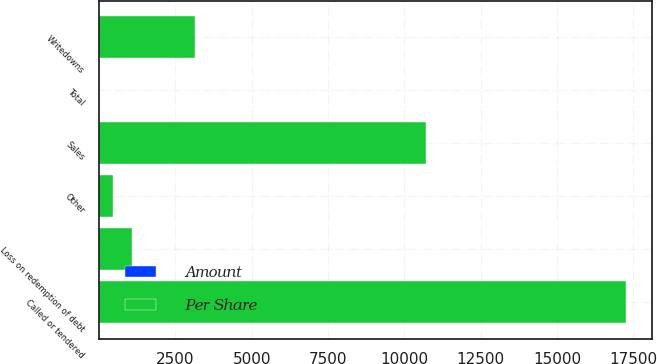<chart> <loc_0><loc_0><loc_500><loc_500><stacked_bar_chart><ecel><fcel>Sales<fcel>Called or tendered<fcel>Writedowns<fcel>Loss on redemption of debt<fcel>Other<fcel>Total<nl><fcel>Per Share<fcel>10699<fcel>17265<fcel>3152<fcel>1070<fcel>466<fcel>0.3<nl><fcel>Amount<fcel>0.13<fcel>0.21<fcel>0.04<fcel>0.01<fcel>0.01<fcel>0.3<nl></chart> 